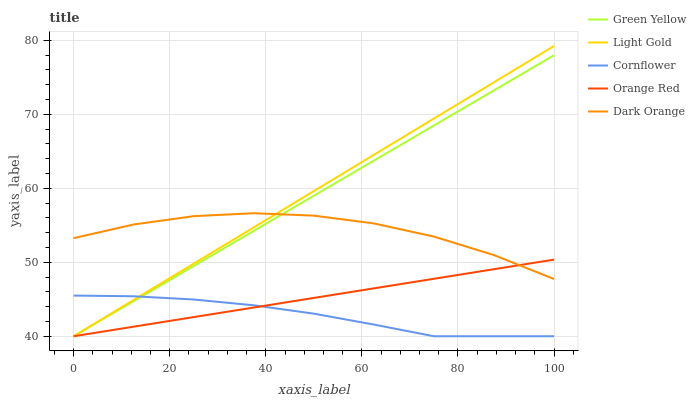Does Cornflower have the minimum area under the curve?
Answer yes or no. Yes. Does Light Gold have the maximum area under the curve?
Answer yes or no. Yes. Does Green Yellow have the minimum area under the curve?
Answer yes or no. No. Does Green Yellow have the maximum area under the curve?
Answer yes or no. No. Is Green Yellow the smoothest?
Answer yes or no. Yes. Is Dark Orange the roughest?
Answer yes or no. Yes. Is Orange Red the smoothest?
Answer yes or no. No. Is Orange Red the roughest?
Answer yes or no. No. Does Dark Orange have the lowest value?
Answer yes or no. No. Does Light Gold have the highest value?
Answer yes or no. Yes. Does Green Yellow have the highest value?
Answer yes or no. No. Is Cornflower less than Dark Orange?
Answer yes or no. Yes. Is Dark Orange greater than Cornflower?
Answer yes or no. Yes. Does Cornflower intersect Green Yellow?
Answer yes or no. Yes. Is Cornflower less than Green Yellow?
Answer yes or no. No. Is Cornflower greater than Green Yellow?
Answer yes or no. No. Does Cornflower intersect Dark Orange?
Answer yes or no. No. 